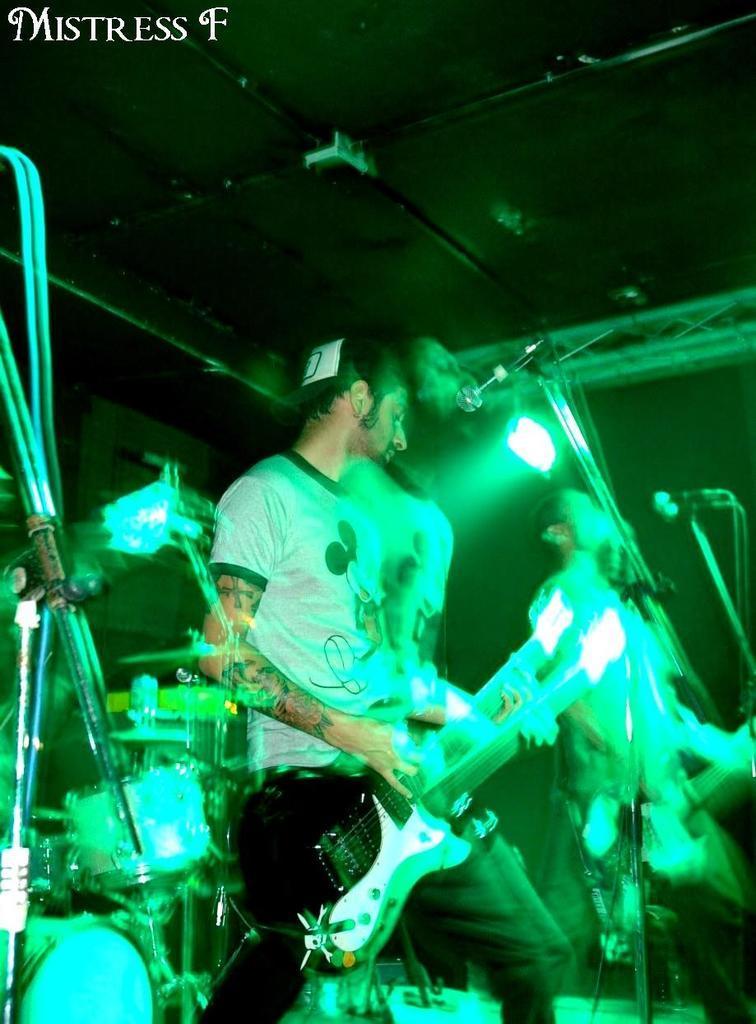Please provide a concise description of this image. In this image we can see two persons are playing musical instruments. There are mikes and lights. In the background we can see wall. At the top of the image we can see ceiling and some text. 